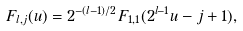Convert formula to latex. <formula><loc_0><loc_0><loc_500><loc_500>F _ { l , j } ( u ) = 2 ^ { - ( l - 1 ) / 2 } F _ { 1 , 1 } ( 2 ^ { l - 1 } u - j + 1 ) ,</formula> 